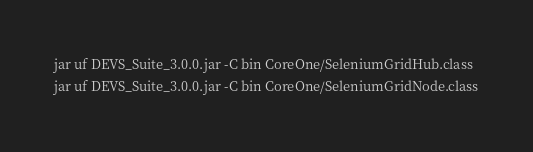<code> <loc_0><loc_0><loc_500><loc_500><_Bash_>jar uf DEVS_Suite_3.0.0.jar -C bin CoreOne/SeleniumGridHub.class
jar uf DEVS_Suite_3.0.0.jar -C bin CoreOne/SeleniumGridNode.class
</code> 